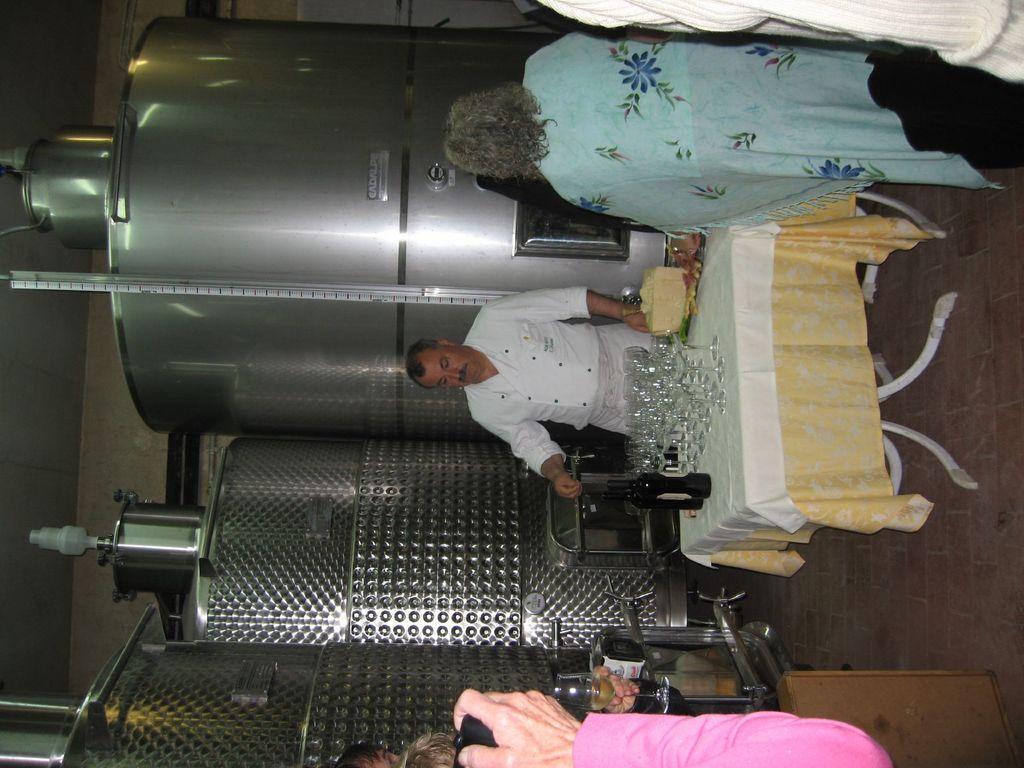Could you give a brief overview of what you see in this image? In the image I can see people among them some are holding glasses. I can also see a table which has bottles, glass and covered with cloth. In the background I can see machines, wall and some other objects. 